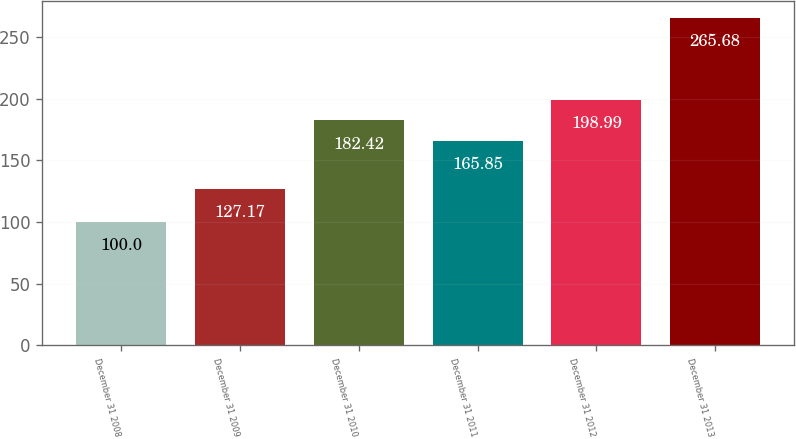Convert chart to OTSL. <chart><loc_0><loc_0><loc_500><loc_500><bar_chart><fcel>December 31 2008<fcel>December 31 2009<fcel>December 31 2010<fcel>December 31 2011<fcel>December 31 2012<fcel>December 31 2013<nl><fcel>100<fcel>127.17<fcel>182.42<fcel>165.85<fcel>198.99<fcel>265.68<nl></chart> 